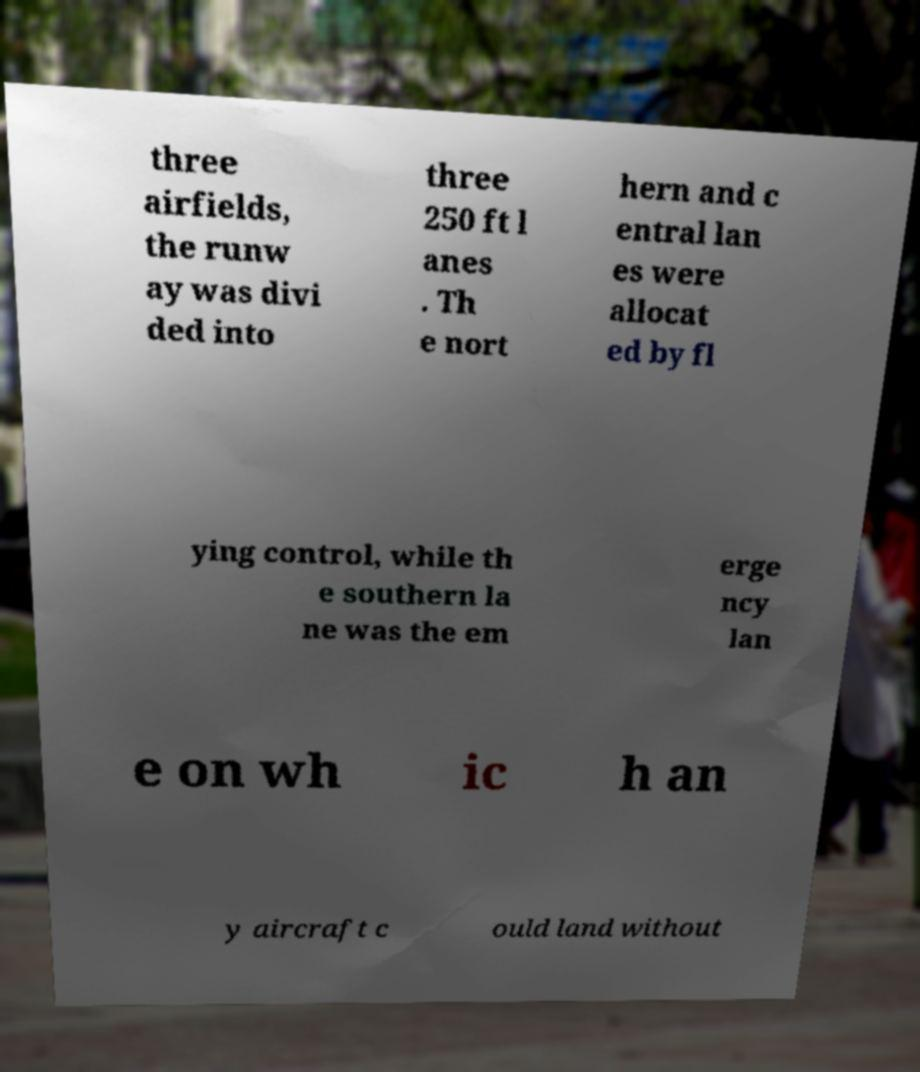Can you read and provide the text displayed in the image?This photo seems to have some interesting text. Can you extract and type it out for me? three airfields, the runw ay was divi ded into three 250 ft l anes . Th e nort hern and c entral lan es were allocat ed by fl ying control, while th e southern la ne was the em erge ncy lan e on wh ic h an y aircraft c ould land without 